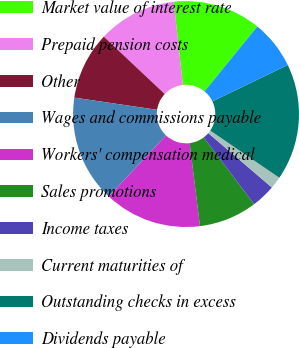<chart> <loc_0><loc_0><loc_500><loc_500><pie_chart><fcel>Market value of interest rate<fcel>Prepaid pension costs<fcel>Other<fcel>Wages and commissions payable<fcel>Workers' compensation medical<fcel>Sales promotions<fcel>Income taxes<fcel>Current maturities of<fcel>Outstanding checks in excess<fcel>Dividends payable<nl><fcel>12.61%<fcel>11.25%<fcel>9.69%<fcel>15.33%<fcel>13.97%<fcel>8.33%<fcel>3.44%<fcel>1.73%<fcel>16.69%<fcel>6.97%<nl></chart> 